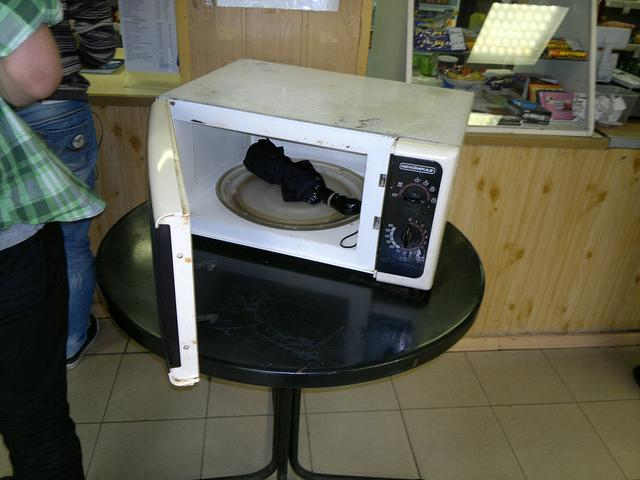Inside what is the umbrella? Please explain your reasoning. microwave. You can tell by the shape of the appliance to where the umbrella is in. 